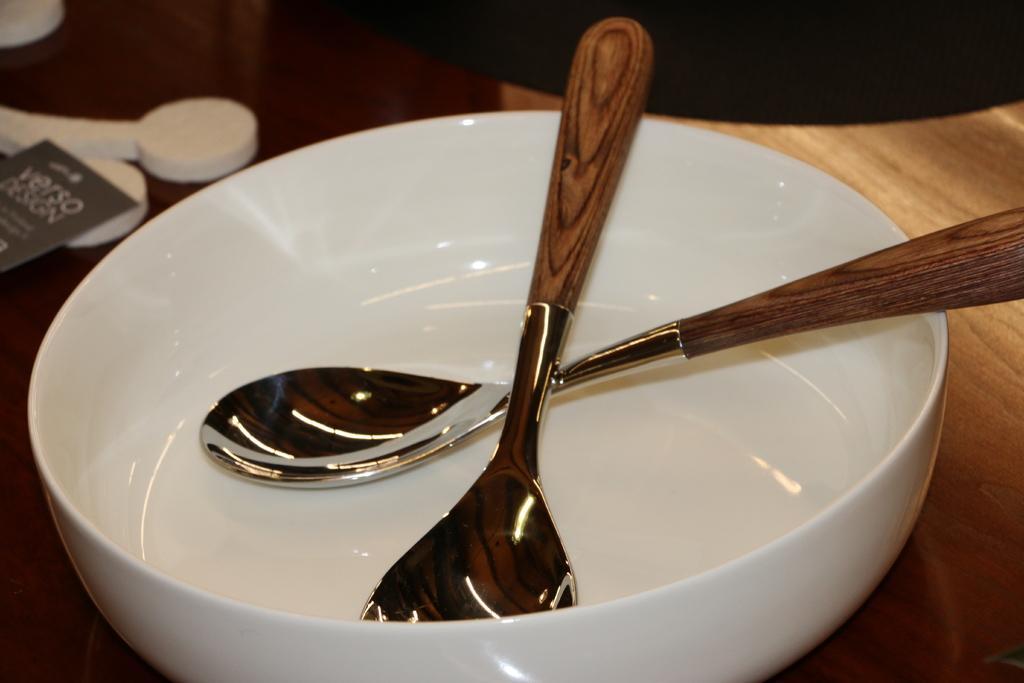Can you describe this image briefly? In the foreground of this image, on a wooden surface, there is a white bowl on which two spoons are present. In the background, there are three white objects and a cardboard is present on it. 